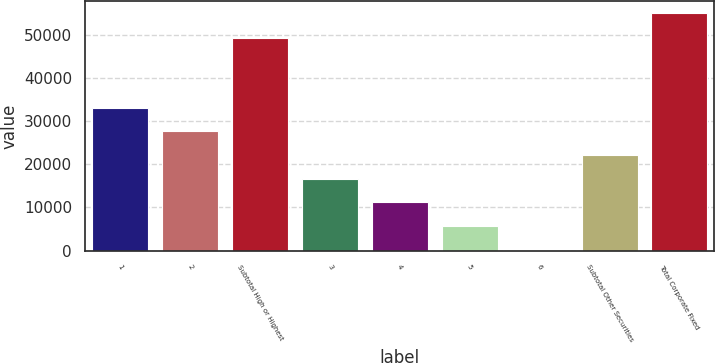Convert chart to OTSL. <chart><loc_0><loc_0><loc_500><loc_500><bar_chart><fcel>1<fcel>2<fcel>Subtotal High or Highest<fcel>3<fcel>4<fcel>5<fcel>6<fcel>Subtotal Other Securities<fcel>Total Corporate Fixed<nl><fcel>33115.4<fcel>27624.5<fcel>49213<fcel>16642.7<fcel>11151.8<fcel>5660.9<fcel>170<fcel>22133.6<fcel>55079<nl></chart> 